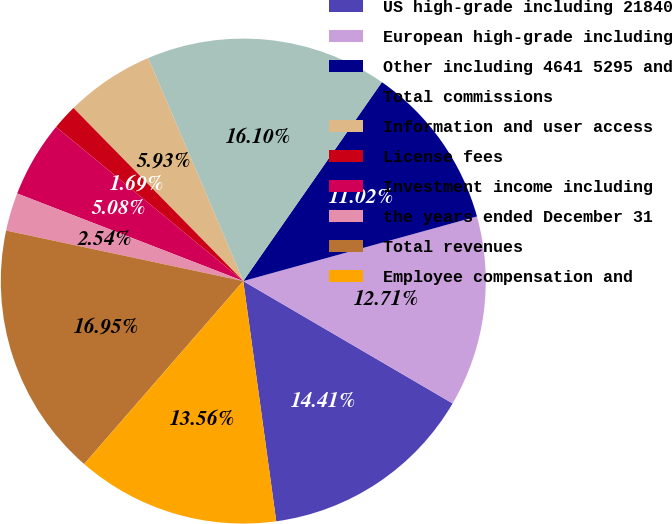Convert chart to OTSL. <chart><loc_0><loc_0><loc_500><loc_500><pie_chart><fcel>US high-grade including 21840<fcel>European high-grade including<fcel>Other including 4641 5295 and<fcel>Total commissions<fcel>Information and user access<fcel>License fees<fcel>Investment income including<fcel>the years ended December 31<fcel>Total revenues<fcel>Employee compensation and<nl><fcel>14.41%<fcel>12.71%<fcel>11.02%<fcel>16.1%<fcel>5.93%<fcel>1.69%<fcel>5.08%<fcel>2.54%<fcel>16.95%<fcel>13.56%<nl></chart> 